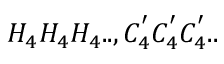Convert formula to latex. <formula><loc_0><loc_0><loc_500><loc_500>H _ { 4 } H _ { 4 } H _ { 4 } . . , C _ { 4 } ^ { ^ { \prime } } C _ { 4 } ^ { ^ { \prime } } C _ { 4 } ^ { ^ { \prime } } . .</formula> 